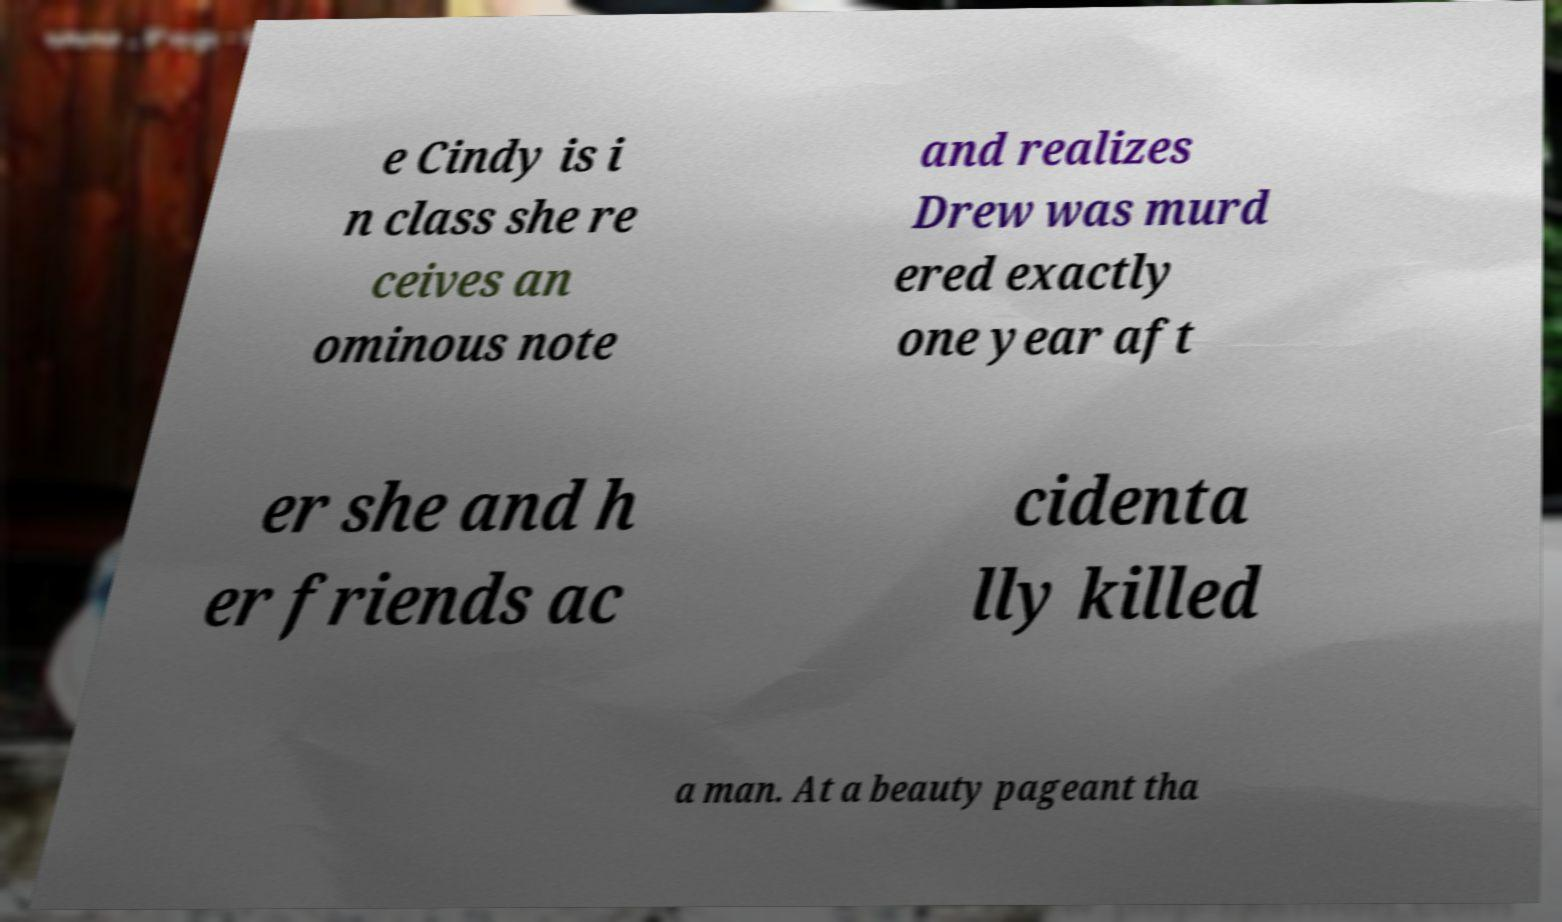There's text embedded in this image that I need extracted. Can you transcribe it verbatim? e Cindy is i n class she re ceives an ominous note and realizes Drew was murd ered exactly one year aft er she and h er friends ac cidenta lly killed a man. At a beauty pageant tha 